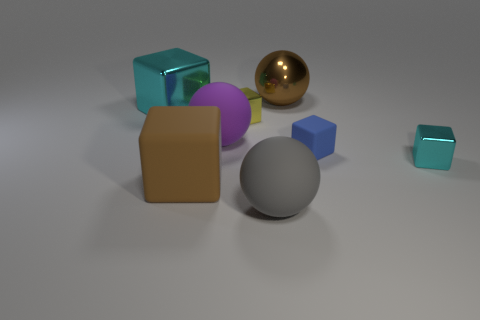Subtract all large cyan blocks. How many blocks are left? 4 Subtract all yellow cubes. How many cubes are left? 4 Add 2 big green metal cylinders. How many objects exist? 10 Subtract all gray blocks. Subtract all purple balls. How many blocks are left? 5 Subtract all balls. How many objects are left? 5 Add 4 small cubes. How many small cubes are left? 7 Add 2 big blue cylinders. How many big blue cylinders exist? 2 Subtract 1 yellow blocks. How many objects are left? 7 Subtract all blocks. Subtract all gray balls. How many objects are left? 2 